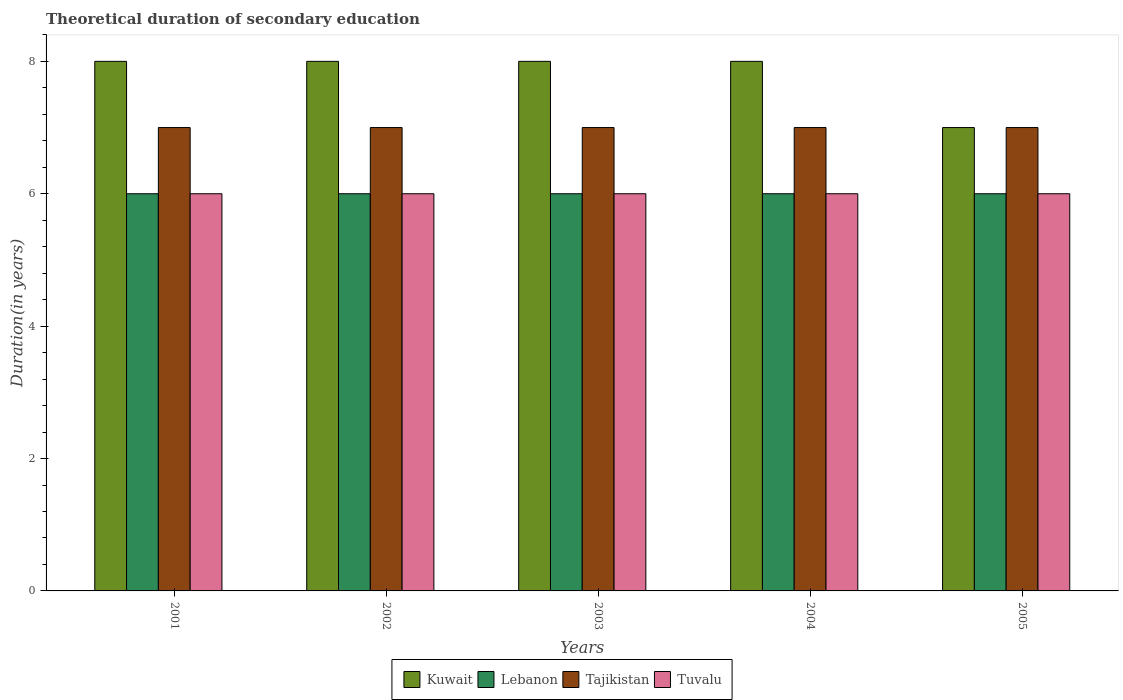How many groups of bars are there?
Keep it short and to the point. 5. Are the number of bars per tick equal to the number of legend labels?
Your answer should be very brief. Yes. Are the number of bars on each tick of the X-axis equal?
Provide a short and direct response. Yes. How many bars are there on the 5th tick from the left?
Make the answer very short. 4. How many bars are there on the 4th tick from the right?
Your answer should be very brief. 4. What is the label of the 2nd group of bars from the left?
Offer a very short reply. 2002. In how many cases, is the number of bars for a given year not equal to the number of legend labels?
Offer a terse response. 0. What is the total theoretical duration of secondary education in Tajikistan in 2001?
Give a very brief answer. 7. Across all years, what is the maximum total theoretical duration of secondary education in Lebanon?
Your answer should be very brief. 6. Across all years, what is the minimum total theoretical duration of secondary education in Tajikistan?
Give a very brief answer. 7. In which year was the total theoretical duration of secondary education in Kuwait maximum?
Ensure brevity in your answer.  2001. In which year was the total theoretical duration of secondary education in Tuvalu minimum?
Your answer should be very brief. 2001. What is the total total theoretical duration of secondary education in Kuwait in the graph?
Make the answer very short. 39. What is the difference between the total theoretical duration of secondary education in Kuwait in 2002 and that in 2003?
Your response must be concise. 0. What is the difference between the total theoretical duration of secondary education in Lebanon in 2003 and the total theoretical duration of secondary education in Kuwait in 2005?
Give a very brief answer. -1. What is the average total theoretical duration of secondary education in Tajikistan per year?
Offer a very short reply. 7. In the year 2001, what is the difference between the total theoretical duration of secondary education in Tuvalu and total theoretical duration of secondary education in Kuwait?
Offer a very short reply. -2. What is the ratio of the total theoretical duration of secondary education in Kuwait in 2001 to that in 2004?
Your answer should be compact. 1. Is the total theoretical duration of secondary education in Tuvalu in 2001 less than that in 2003?
Keep it short and to the point. No. What is the difference between the highest and the second highest total theoretical duration of secondary education in Lebanon?
Your answer should be compact. 0. What is the difference between the highest and the lowest total theoretical duration of secondary education in Lebanon?
Provide a succinct answer. 0. Is it the case that in every year, the sum of the total theoretical duration of secondary education in Tuvalu and total theoretical duration of secondary education in Lebanon is greater than the sum of total theoretical duration of secondary education in Kuwait and total theoretical duration of secondary education in Tajikistan?
Your answer should be very brief. No. What does the 4th bar from the left in 2003 represents?
Your answer should be very brief. Tuvalu. What does the 4th bar from the right in 2005 represents?
Give a very brief answer. Kuwait. How many bars are there?
Keep it short and to the point. 20. Are all the bars in the graph horizontal?
Provide a succinct answer. No. How many years are there in the graph?
Your answer should be very brief. 5. What is the difference between two consecutive major ticks on the Y-axis?
Provide a short and direct response. 2. Are the values on the major ticks of Y-axis written in scientific E-notation?
Offer a terse response. No. Does the graph contain any zero values?
Provide a short and direct response. No. Does the graph contain grids?
Your answer should be compact. No. Where does the legend appear in the graph?
Ensure brevity in your answer.  Bottom center. How many legend labels are there?
Provide a short and direct response. 4. How are the legend labels stacked?
Make the answer very short. Horizontal. What is the title of the graph?
Your response must be concise. Theoretical duration of secondary education. What is the label or title of the Y-axis?
Give a very brief answer. Duration(in years). What is the Duration(in years) in Kuwait in 2001?
Offer a terse response. 8. What is the Duration(in years) of Lebanon in 2001?
Keep it short and to the point. 6. What is the Duration(in years) of Tajikistan in 2001?
Offer a very short reply. 7. What is the Duration(in years) in Tuvalu in 2001?
Offer a very short reply. 6. What is the Duration(in years) in Kuwait in 2002?
Keep it short and to the point. 8. What is the Duration(in years) in Lebanon in 2002?
Ensure brevity in your answer.  6. What is the Duration(in years) in Tajikistan in 2002?
Keep it short and to the point. 7. What is the Duration(in years) of Tuvalu in 2002?
Keep it short and to the point. 6. What is the Duration(in years) in Tuvalu in 2003?
Your response must be concise. 6. What is the Duration(in years) in Lebanon in 2004?
Provide a succinct answer. 6. What is the Duration(in years) of Kuwait in 2005?
Give a very brief answer. 7. What is the Duration(in years) in Tuvalu in 2005?
Your answer should be compact. 6. Across all years, what is the maximum Duration(in years) in Tuvalu?
Offer a very short reply. 6. Across all years, what is the minimum Duration(in years) of Kuwait?
Offer a very short reply. 7. Across all years, what is the minimum Duration(in years) in Tajikistan?
Provide a succinct answer. 7. What is the total Duration(in years) of Kuwait in the graph?
Provide a short and direct response. 39. What is the total Duration(in years) in Lebanon in the graph?
Your answer should be compact. 30. What is the total Duration(in years) of Tuvalu in the graph?
Your answer should be very brief. 30. What is the difference between the Duration(in years) of Kuwait in 2001 and that in 2002?
Keep it short and to the point. 0. What is the difference between the Duration(in years) of Tajikistan in 2001 and that in 2002?
Your answer should be compact. 0. What is the difference between the Duration(in years) in Tuvalu in 2001 and that in 2002?
Offer a very short reply. 0. What is the difference between the Duration(in years) in Kuwait in 2001 and that in 2003?
Offer a terse response. 0. What is the difference between the Duration(in years) in Lebanon in 2001 and that in 2003?
Your answer should be compact. 0. What is the difference between the Duration(in years) in Kuwait in 2001 and that in 2004?
Your response must be concise. 0. What is the difference between the Duration(in years) of Lebanon in 2001 and that in 2004?
Your answer should be compact. 0. What is the difference between the Duration(in years) in Tajikistan in 2001 and that in 2004?
Your answer should be very brief. 0. What is the difference between the Duration(in years) of Tuvalu in 2001 and that in 2004?
Offer a terse response. 0. What is the difference between the Duration(in years) of Tuvalu in 2001 and that in 2005?
Provide a short and direct response. 0. What is the difference between the Duration(in years) of Lebanon in 2002 and that in 2003?
Offer a terse response. 0. What is the difference between the Duration(in years) of Tajikistan in 2002 and that in 2003?
Give a very brief answer. 0. What is the difference between the Duration(in years) in Kuwait in 2002 and that in 2004?
Your answer should be compact. 0. What is the difference between the Duration(in years) of Tajikistan in 2002 and that in 2004?
Provide a succinct answer. 0. What is the difference between the Duration(in years) of Kuwait in 2002 and that in 2005?
Ensure brevity in your answer.  1. What is the difference between the Duration(in years) of Kuwait in 2003 and that in 2004?
Keep it short and to the point. 0. What is the difference between the Duration(in years) of Tajikistan in 2003 and that in 2005?
Make the answer very short. 0. What is the difference between the Duration(in years) of Lebanon in 2004 and that in 2005?
Ensure brevity in your answer.  0. What is the difference between the Duration(in years) in Tajikistan in 2004 and that in 2005?
Make the answer very short. 0. What is the difference between the Duration(in years) in Tuvalu in 2004 and that in 2005?
Offer a terse response. 0. What is the difference between the Duration(in years) in Kuwait in 2001 and the Duration(in years) in Lebanon in 2002?
Give a very brief answer. 2. What is the difference between the Duration(in years) of Kuwait in 2001 and the Duration(in years) of Tajikistan in 2002?
Your answer should be very brief. 1. What is the difference between the Duration(in years) of Lebanon in 2001 and the Duration(in years) of Tuvalu in 2002?
Your answer should be compact. 0. What is the difference between the Duration(in years) in Kuwait in 2001 and the Duration(in years) in Tajikistan in 2003?
Your answer should be compact. 1. What is the difference between the Duration(in years) of Kuwait in 2001 and the Duration(in years) of Tuvalu in 2003?
Your answer should be compact. 2. What is the difference between the Duration(in years) in Lebanon in 2001 and the Duration(in years) in Tajikistan in 2003?
Keep it short and to the point. -1. What is the difference between the Duration(in years) of Lebanon in 2001 and the Duration(in years) of Tuvalu in 2003?
Offer a very short reply. 0. What is the difference between the Duration(in years) in Tajikistan in 2001 and the Duration(in years) in Tuvalu in 2003?
Provide a short and direct response. 1. What is the difference between the Duration(in years) in Lebanon in 2001 and the Duration(in years) in Tuvalu in 2004?
Offer a terse response. 0. What is the difference between the Duration(in years) of Kuwait in 2001 and the Duration(in years) of Tajikistan in 2005?
Ensure brevity in your answer.  1. What is the difference between the Duration(in years) in Lebanon in 2001 and the Duration(in years) in Tuvalu in 2005?
Offer a terse response. 0. What is the difference between the Duration(in years) of Lebanon in 2002 and the Duration(in years) of Tajikistan in 2003?
Keep it short and to the point. -1. What is the difference between the Duration(in years) in Lebanon in 2002 and the Duration(in years) in Tuvalu in 2003?
Provide a succinct answer. 0. What is the difference between the Duration(in years) in Kuwait in 2002 and the Duration(in years) in Lebanon in 2004?
Offer a terse response. 2. What is the difference between the Duration(in years) of Kuwait in 2002 and the Duration(in years) of Tajikistan in 2004?
Offer a terse response. 1. What is the difference between the Duration(in years) in Kuwait in 2002 and the Duration(in years) in Tuvalu in 2004?
Your response must be concise. 2. What is the difference between the Duration(in years) of Lebanon in 2002 and the Duration(in years) of Tajikistan in 2004?
Make the answer very short. -1. What is the difference between the Duration(in years) of Lebanon in 2002 and the Duration(in years) of Tuvalu in 2004?
Provide a short and direct response. 0. What is the difference between the Duration(in years) of Tajikistan in 2002 and the Duration(in years) of Tuvalu in 2004?
Offer a very short reply. 1. What is the difference between the Duration(in years) of Kuwait in 2002 and the Duration(in years) of Tajikistan in 2005?
Provide a short and direct response. 1. What is the difference between the Duration(in years) in Kuwait in 2003 and the Duration(in years) in Tuvalu in 2004?
Offer a terse response. 2. What is the difference between the Duration(in years) in Lebanon in 2003 and the Duration(in years) in Tajikistan in 2004?
Offer a very short reply. -1. What is the difference between the Duration(in years) in Kuwait in 2003 and the Duration(in years) in Lebanon in 2005?
Offer a terse response. 2. What is the difference between the Duration(in years) of Kuwait in 2003 and the Duration(in years) of Tajikistan in 2005?
Your answer should be very brief. 1. What is the difference between the Duration(in years) of Kuwait in 2003 and the Duration(in years) of Tuvalu in 2005?
Your answer should be very brief. 2. What is the difference between the Duration(in years) in Lebanon in 2003 and the Duration(in years) in Tuvalu in 2005?
Give a very brief answer. 0. What is the difference between the Duration(in years) of Tajikistan in 2003 and the Duration(in years) of Tuvalu in 2005?
Provide a short and direct response. 1. What is the difference between the Duration(in years) in Kuwait in 2004 and the Duration(in years) in Tuvalu in 2005?
Offer a terse response. 2. What is the difference between the Duration(in years) in Lebanon in 2004 and the Duration(in years) in Tuvalu in 2005?
Provide a short and direct response. 0. What is the average Duration(in years) in Kuwait per year?
Offer a very short reply. 7.8. What is the average Duration(in years) of Tuvalu per year?
Keep it short and to the point. 6. In the year 2001, what is the difference between the Duration(in years) in Kuwait and Duration(in years) in Lebanon?
Your answer should be compact. 2. In the year 2001, what is the difference between the Duration(in years) in Kuwait and Duration(in years) in Tuvalu?
Offer a terse response. 2. In the year 2001, what is the difference between the Duration(in years) in Lebanon and Duration(in years) in Tajikistan?
Provide a short and direct response. -1. In the year 2002, what is the difference between the Duration(in years) of Kuwait and Duration(in years) of Lebanon?
Your answer should be very brief. 2. In the year 2002, what is the difference between the Duration(in years) of Kuwait and Duration(in years) of Tajikistan?
Your answer should be very brief. 1. In the year 2002, what is the difference between the Duration(in years) of Lebanon and Duration(in years) of Tajikistan?
Make the answer very short. -1. In the year 2002, what is the difference between the Duration(in years) of Lebanon and Duration(in years) of Tuvalu?
Your answer should be very brief. 0. In the year 2003, what is the difference between the Duration(in years) in Kuwait and Duration(in years) in Tajikistan?
Offer a terse response. 1. In the year 2003, what is the difference between the Duration(in years) in Kuwait and Duration(in years) in Tuvalu?
Offer a very short reply. 2. In the year 2003, what is the difference between the Duration(in years) of Lebanon and Duration(in years) of Tajikistan?
Provide a short and direct response. -1. In the year 2003, what is the difference between the Duration(in years) of Lebanon and Duration(in years) of Tuvalu?
Your answer should be compact. 0. In the year 2003, what is the difference between the Duration(in years) in Tajikistan and Duration(in years) in Tuvalu?
Your response must be concise. 1. In the year 2004, what is the difference between the Duration(in years) of Kuwait and Duration(in years) of Tajikistan?
Your answer should be compact. 1. In the year 2004, what is the difference between the Duration(in years) of Lebanon and Duration(in years) of Tuvalu?
Offer a terse response. 0. In the year 2004, what is the difference between the Duration(in years) in Tajikistan and Duration(in years) in Tuvalu?
Your answer should be compact. 1. In the year 2005, what is the difference between the Duration(in years) of Kuwait and Duration(in years) of Tajikistan?
Keep it short and to the point. 0. In the year 2005, what is the difference between the Duration(in years) in Kuwait and Duration(in years) in Tuvalu?
Your response must be concise. 1. In the year 2005, what is the difference between the Duration(in years) in Lebanon and Duration(in years) in Tuvalu?
Your answer should be compact. 0. What is the ratio of the Duration(in years) of Kuwait in 2001 to that in 2002?
Your response must be concise. 1. What is the ratio of the Duration(in years) in Lebanon in 2001 to that in 2002?
Your answer should be very brief. 1. What is the ratio of the Duration(in years) of Kuwait in 2001 to that in 2003?
Provide a succinct answer. 1. What is the ratio of the Duration(in years) in Lebanon in 2001 to that in 2004?
Offer a terse response. 1. What is the ratio of the Duration(in years) of Lebanon in 2001 to that in 2005?
Your response must be concise. 1. What is the ratio of the Duration(in years) of Kuwait in 2002 to that in 2003?
Offer a very short reply. 1. What is the ratio of the Duration(in years) of Lebanon in 2002 to that in 2003?
Provide a succinct answer. 1. What is the ratio of the Duration(in years) in Tajikistan in 2002 to that in 2003?
Your answer should be compact. 1. What is the ratio of the Duration(in years) in Lebanon in 2002 to that in 2004?
Make the answer very short. 1. What is the ratio of the Duration(in years) in Tajikistan in 2002 to that in 2004?
Give a very brief answer. 1. What is the ratio of the Duration(in years) in Tuvalu in 2002 to that in 2004?
Provide a succinct answer. 1. What is the ratio of the Duration(in years) in Kuwait in 2002 to that in 2005?
Your answer should be very brief. 1.14. What is the ratio of the Duration(in years) of Lebanon in 2002 to that in 2005?
Your answer should be very brief. 1. What is the ratio of the Duration(in years) in Tajikistan in 2002 to that in 2005?
Your answer should be compact. 1. What is the ratio of the Duration(in years) in Tuvalu in 2002 to that in 2005?
Your response must be concise. 1. What is the ratio of the Duration(in years) of Kuwait in 2003 to that in 2004?
Your response must be concise. 1. What is the ratio of the Duration(in years) in Lebanon in 2003 to that in 2004?
Provide a short and direct response. 1. What is the ratio of the Duration(in years) of Kuwait in 2003 to that in 2005?
Your answer should be compact. 1.14. What is the ratio of the Duration(in years) of Tajikistan in 2003 to that in 2005?
Offer a very short reply. 1. What is the ratio of the Duration(in years) of Tuvalu in 2003 to that in 2005?
Give a very brief answer. 1. What is the ratio of the Duration(in years) of Kuwait in 2004 to that in 2005?
Keep it short and to the point. 1.14. What is the ratio of the Duration(in years) of Lebanon in 2004 to that in 2005?
Make the answer very short. 1. What is the ratio of the Duration(in years) in Tuvalu in 2004 to that in 2005?
Give a very brief answer. 1. What is the difference between the highest and the second highest Duration(in years) of Kuwait?
Give a very brief answer. 0. What is the difference between the highest and the second highest Duration(in years) of Tajikistan?
Your answer should be very brief. 0. What is the difference between the highest and the lowest Duration(in years) of Kuwait?
Your answer should be very brief. 1. 